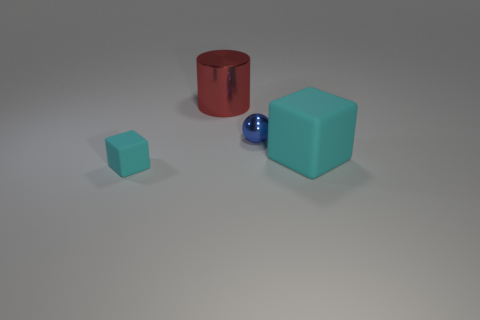Are there the same number of small shiny things left of the sphere and tiny red shiny cubes?
Make the answer very short. Yes. Are the small object that is right of the small matte cube and the large red object made of the same material?
Your answer should be very brief. Yes. Is the number of tiny cyan matte objects to the right of the tiny blue thing less than the number of gray matte spheres?
Provide a short and direct response. No. What number of rubber things are cyan spheres or tiny blue things?
Provide a succinct answer. 0. Is the small matte cube the same color as the big matte cube?
Your answer should be very brief. Yes. Are there any other things that are the same color as the ball?
Make the answer very short. No. There is a cyan matte thing that is behind the tiny block; is its shape the same as the tiny object left of the red shiny cylinder?
Your response must be concise. Yes. How many things are big cyan things or objects behind the large cyan rubber block?
Keep it short and to the point. 3. What number of other things are the same size as the blue metal ball?
Offer a very short reply. 1. Is the material of the cyan cube to the right of the large metallic object the same as the object that is on the left side of the large metal thing?
Provide a short and direct response. Yes. 